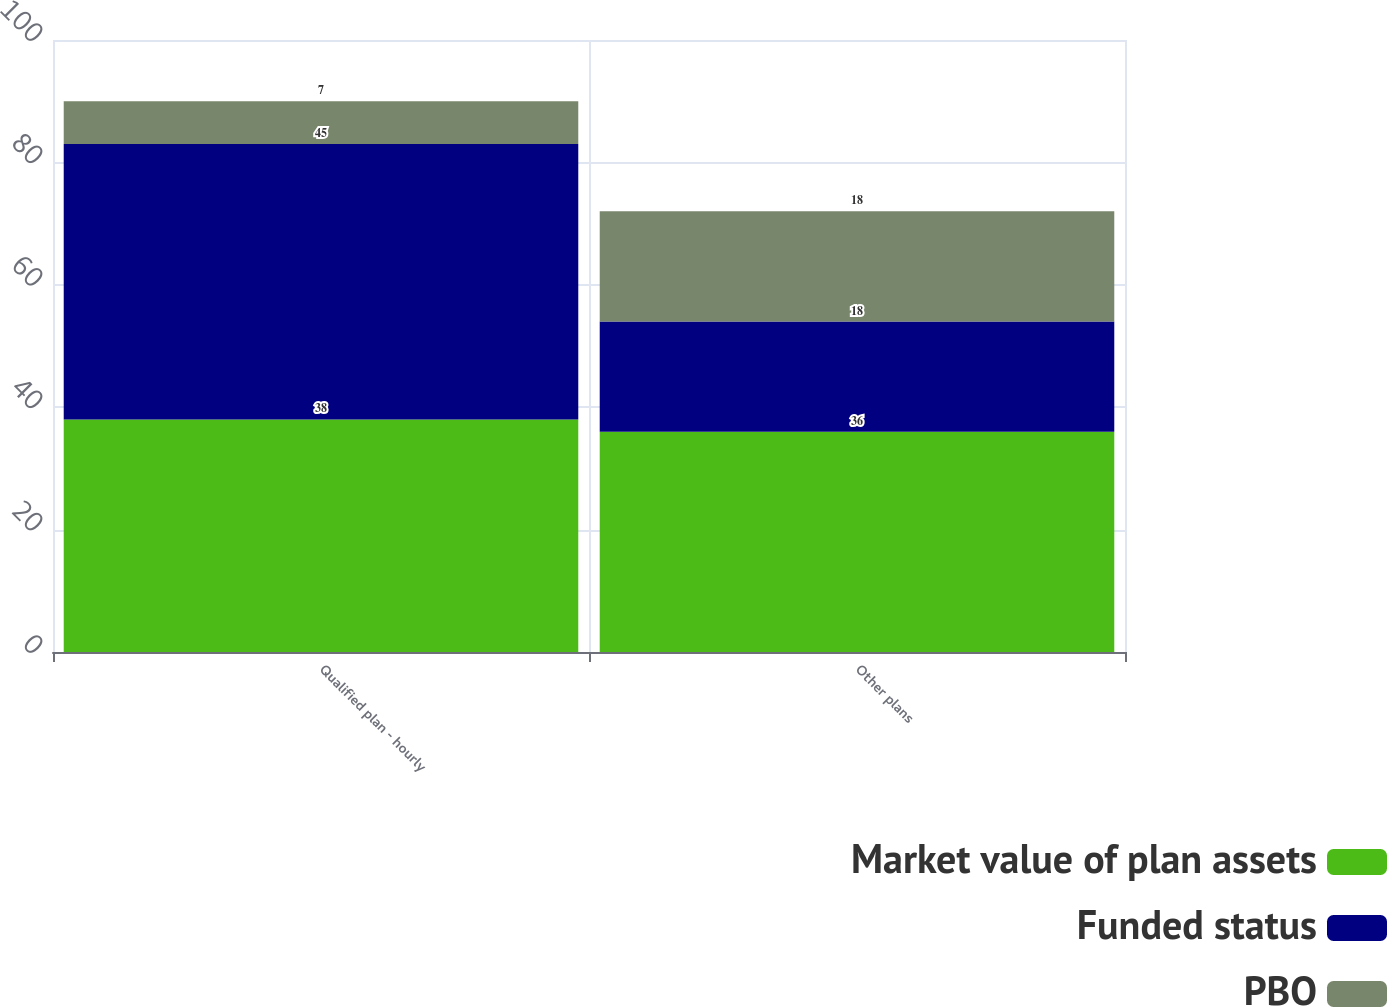Convert chart. <chart><loc_0><loc_0><loc_500><loc_500><stacked_bar_chart><ecel><fcel>Qualified plan - hourly<fcel>Other plans<nl><fcel>Market value of plan assets<fcel>38<fcel>36<nl><fcel>Funded status<fcel>45<fcel>18<nl><fcel>PBO<fcel>7<fcel>18<nl></chart> 